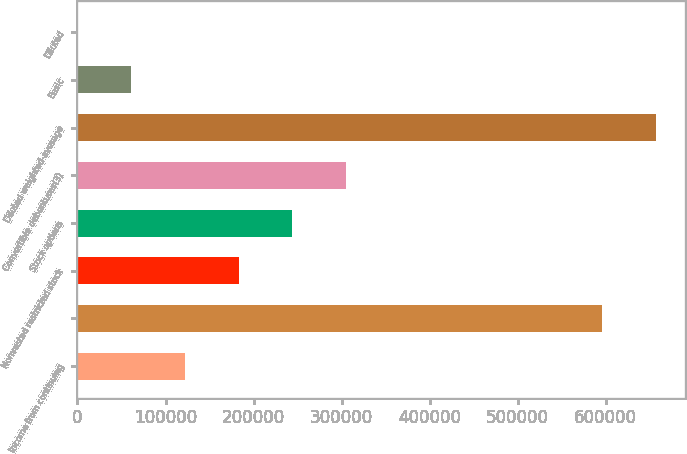Convert chart to OTSL. <chart><loc_0><loc_0><loc_500><loc_500><bar_chart><fcel>Income from continuing<fcel>Unnamed: 1<fcel>Nonvested restricted stock<fcel>Stock options<fcel>Convertible debentures(3)<fcel>Diluted weighted-average<fcel>Basic<fcel>Diluted<nl><fcel>121974<fcel>596174<fcel>182961<fcel>243947<fcel>304934<fcel>657160<fcel>60987.9<fcel>1.4<nl></chart> 